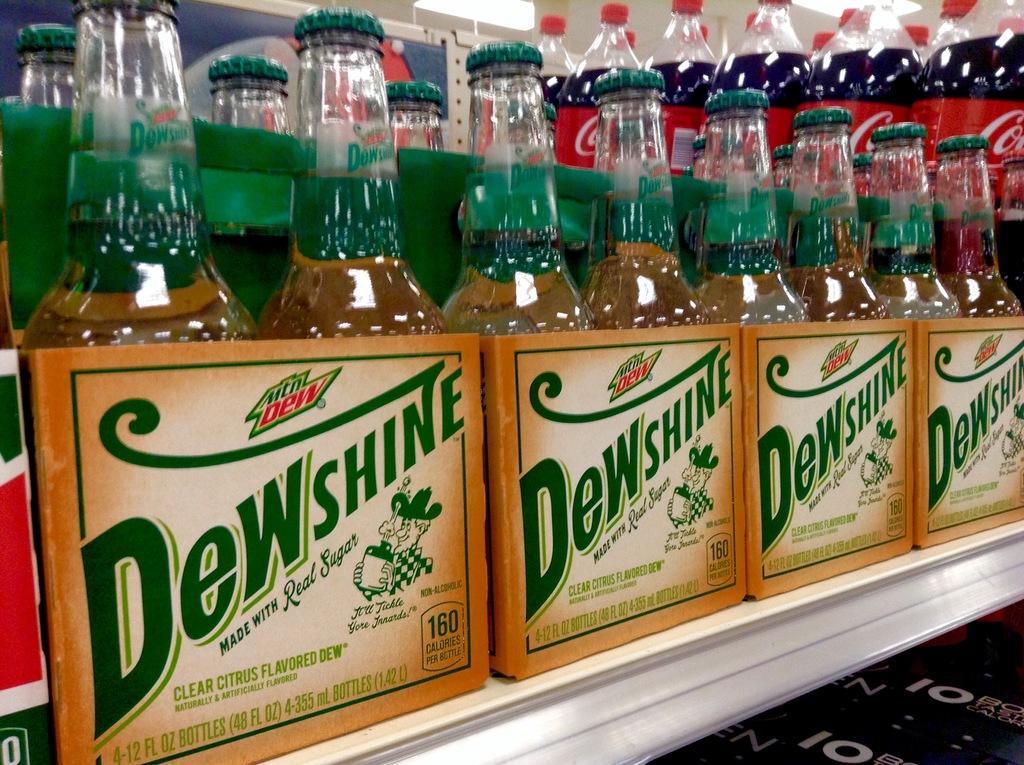How many calories are in each bottle of dewshine?
Your answer should be very brief. 160. What is dewshine made with?
Your response must be concise. Real sugar. 